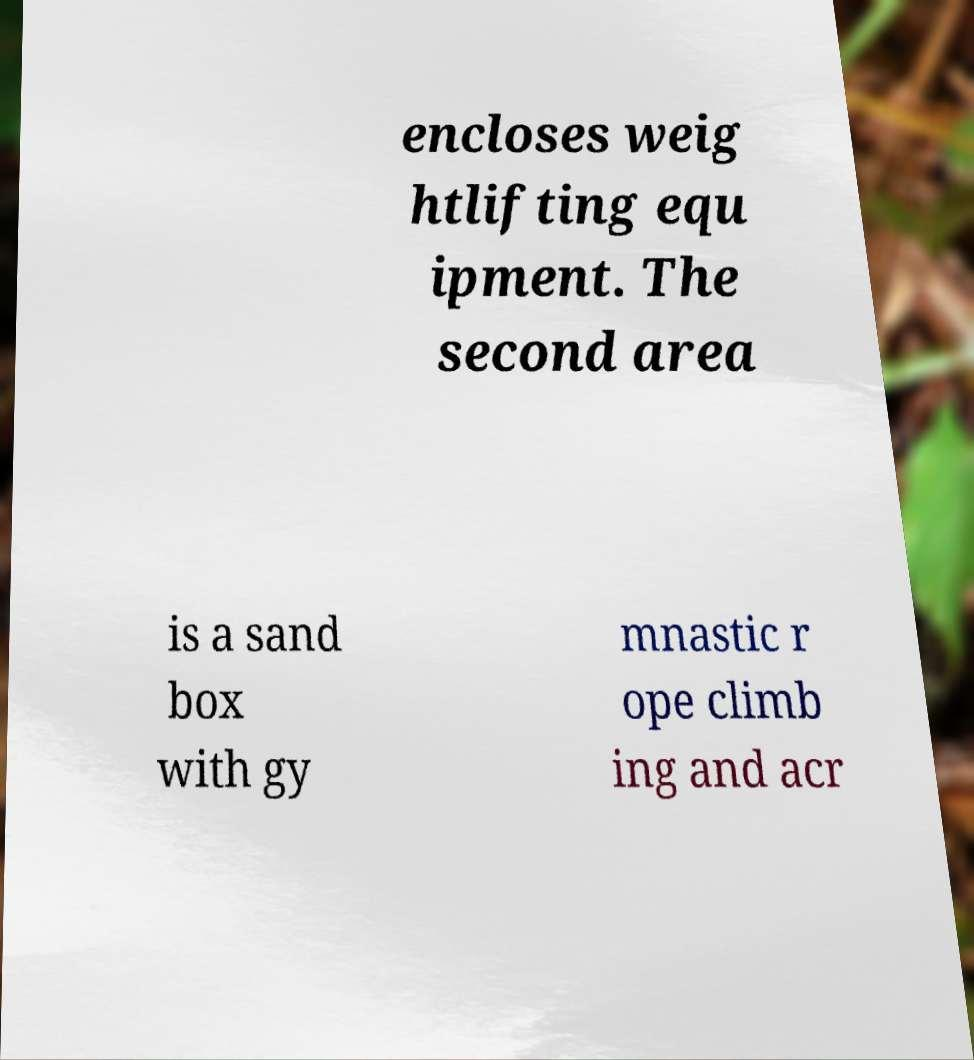Could you assist in decoding the text presented in this image and type it out clearly? encloses weig htlifting equ ipment. The second area is a sand box with gy mnastic r ope climb ing and acr 